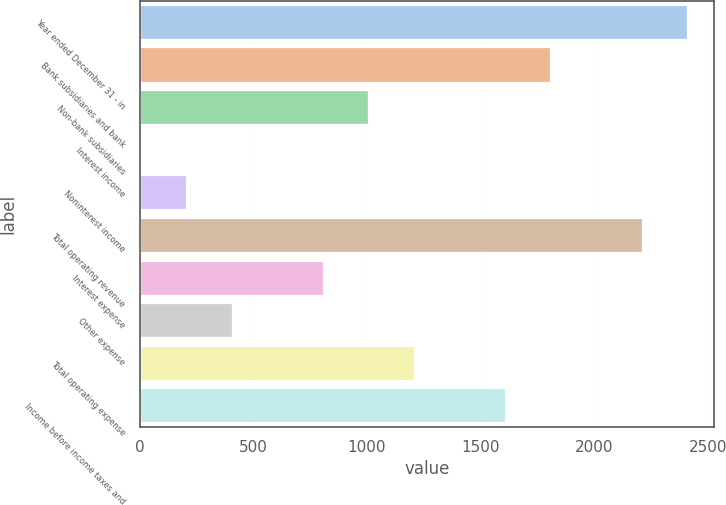Convert chart to OTSL. <chart><loc_0><loc_0><loc_500><loc_500><bar_chart><fcel>Year ended December 31 - in<fcel>Bank subsidiaries and bank<fcel>Non-bank subsidiaries<fcel>Interest income<fcel>Noninterest income<fcel>Total operating revenue<fcel>Interest expense<fcel>Other expense<fcel>Total operating expense<fcel>Income before income taxes and<nl><fcel>2408.8<fcel>1807.6<fcel>1006<fcel>4<fcel>204.4<fcel>2208.4<fcel>805.6<fcel>404.8<fcel>1206.4<fcel>1607.2<nl></chart> 